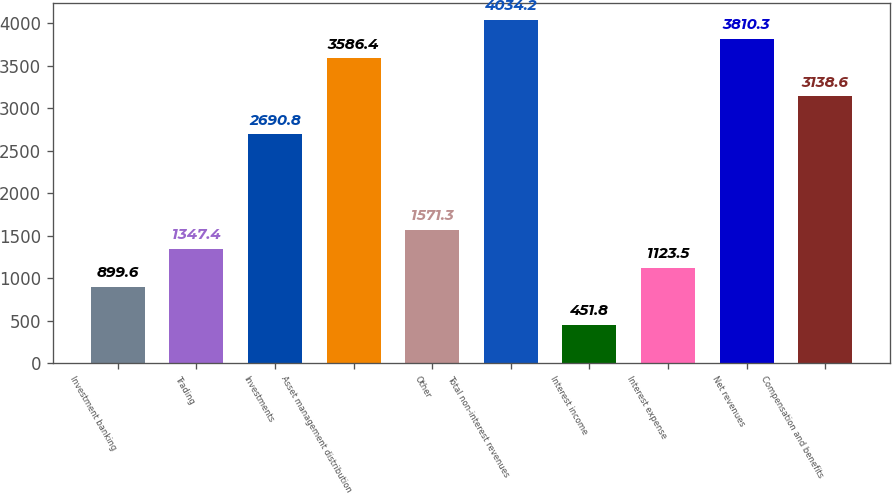Convert chart. <chart><loc_0><loc_0><loc_500><loc_500><bar_chart><fcel>Investment banking<fcel>Trading<fcel>Investments<fcel>Asset management distribution<fcel>Other<fcel>Total non-interest revenues<fcel>Interest income<fcel>Interest expense<fcel>Net revenues<fcel>Compensation and benefits<nl><fcel>899.6<fcel>1347.4<fcel>2690.8<fcel>3586.4<fcel>1571.3<fcel>4034.2<fcel>451.8<fcel>1123.5<fcel>3810.3<fcel>3138.6<nl></chart> 